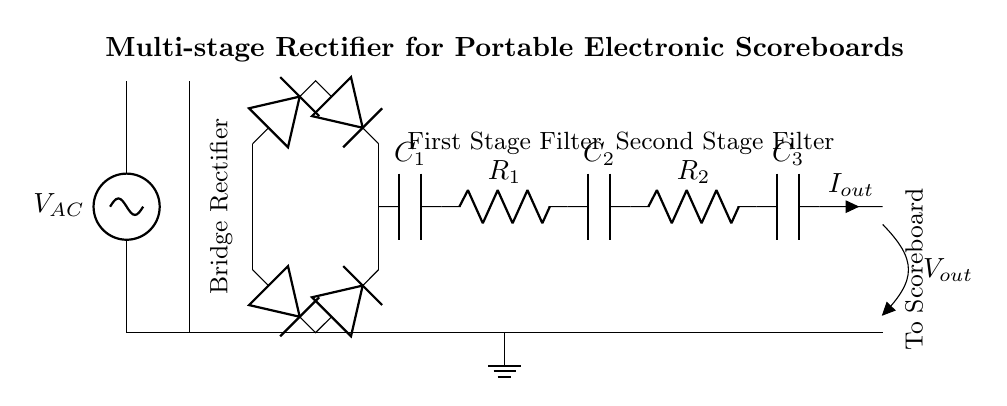What is the input voltage type for this rectifier circuit? The input voltage type is alternating current, indicated by the AC voltage source labeled V_AC at the input.
Answer: alternating current How many diodes are used in the bridge rectifier? The bridge rectifier consists of four diodes arranged to allow current to pass in both directions.
Answer: four What is the function of the capacitor labeled C1? Capacitor C1 acts as a smoothing capacitor, reducing ripples in the output voltage after rectification, so it helps to stabilize the output.
Answer: smoothing What components are part of the first stage filter? The first stage filter includes the resistor R1 and capacitor C2, which work together to further smooth the output voltage after the initial rectification.
Answer: resistor R1 and capacitor C2 What is the purpose of the transformer in this circuit? The transformer steps down the input AC voltage to a lower voltage suitable for the rectification process, making it safe for the portable scoreboard operation.
Answer: step down voltage How does the output current relate to the components in the circuit? The output current, labeled I_out, flows from the last capacitor (C3) after passing through the filters, which means it is affected by the resistors R1 and R2 in the filtering stages.
Answer: affected by R1 and R2 What is the total number of filter stages in this rectifier circuit? The circuit contains two filter stages that help in reducing the voltage ripple, indicated by the presence of R1, C2 for the first stage, and R2, C3 for the second stage.
Answer: two 